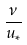<formula> <loc_0><loc_0><loc_500><loc_500>\frac { \nu } { u _ { * } }</formula> 